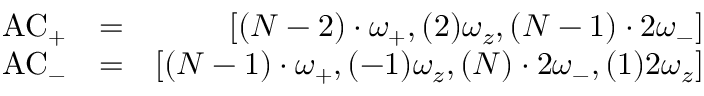<formula> <loc_0><loc_0><loc_500><loc_500>\begin{array} { r l r } { A C _ { + } } & { = } & { \left [ ( N - 2 ) \cdot \omega _ { + } , ( 2 ) \omega _ { z } , ( N - 1 ) \cdot 2 \omega _ { - } \right ] } \\ { A C _ { - } } & { = } & { \left [ ( N - 1 ) \cdot \omega _ { + } , ( - 1 ) \omega _ { z } , ( N ) \cdot 2 \omega _ { - } , ( 1 ) 2 \omega _ { z } \right ] } \end{array}</formula> 